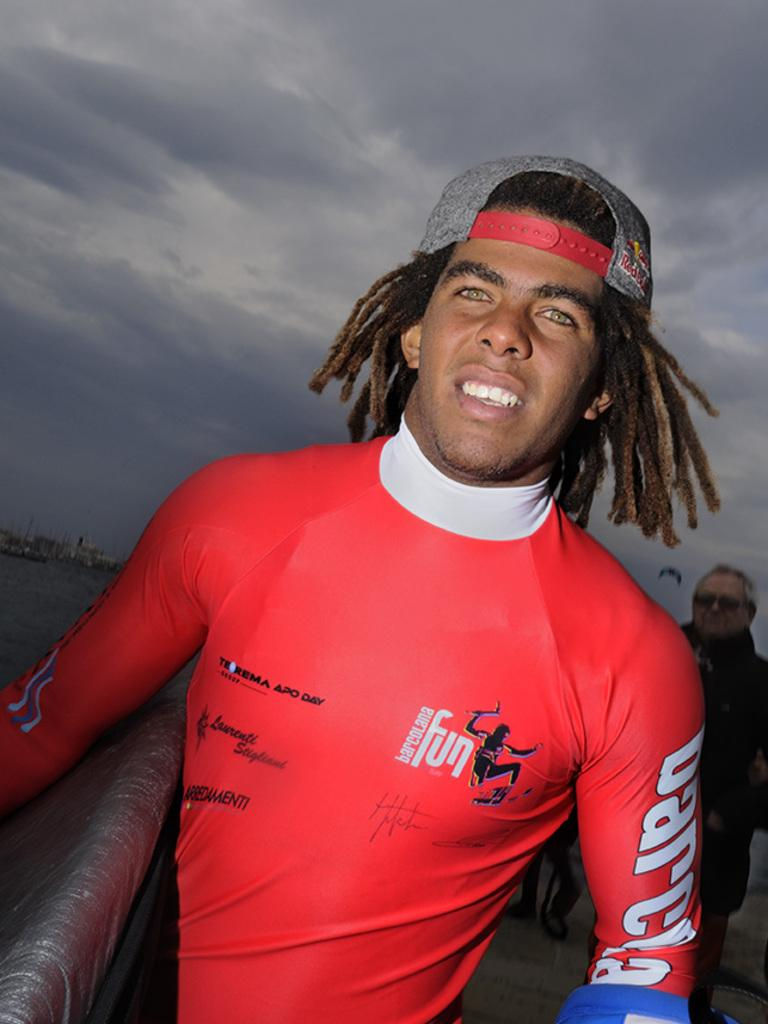Provide a one-sentence caption for the provided image. man with a surfboard and dreadlock hair at the beach. 